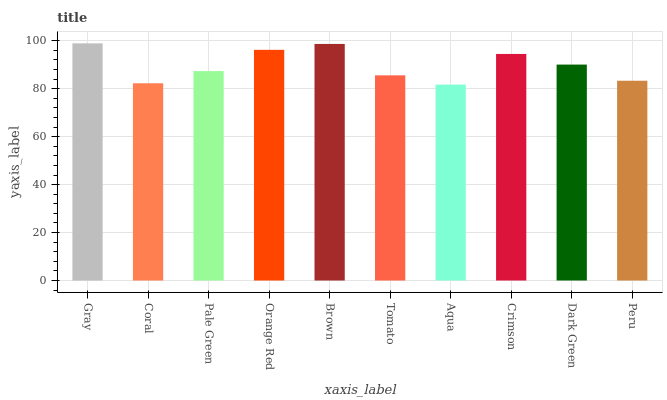Is Aqua the minimum?
Answer yes or no. Yes. Is Gray the maximum?
Answer yes or no. Yes. Is Coral the minimum?
Answer yes or no. No. Is Coral the maximum?
Answer yes or no. No. Is Gray greater than Coral?
Answer yes or no. Yes. Is Coral less than Gray?
Answer yes or no. Yes. Is Coral greater than Gray?
Answer yes or no. No. Is Gray less than Coral?
Answer yes or no. No. Is Dark Green the high median?
Answer yes or no. Yes. Is Pale Green the low median?
Answer yes or no. Yes. Is Coral the high median?
Answer yes or no. No. Is Coral the low median?
Answer yes or no. No. 